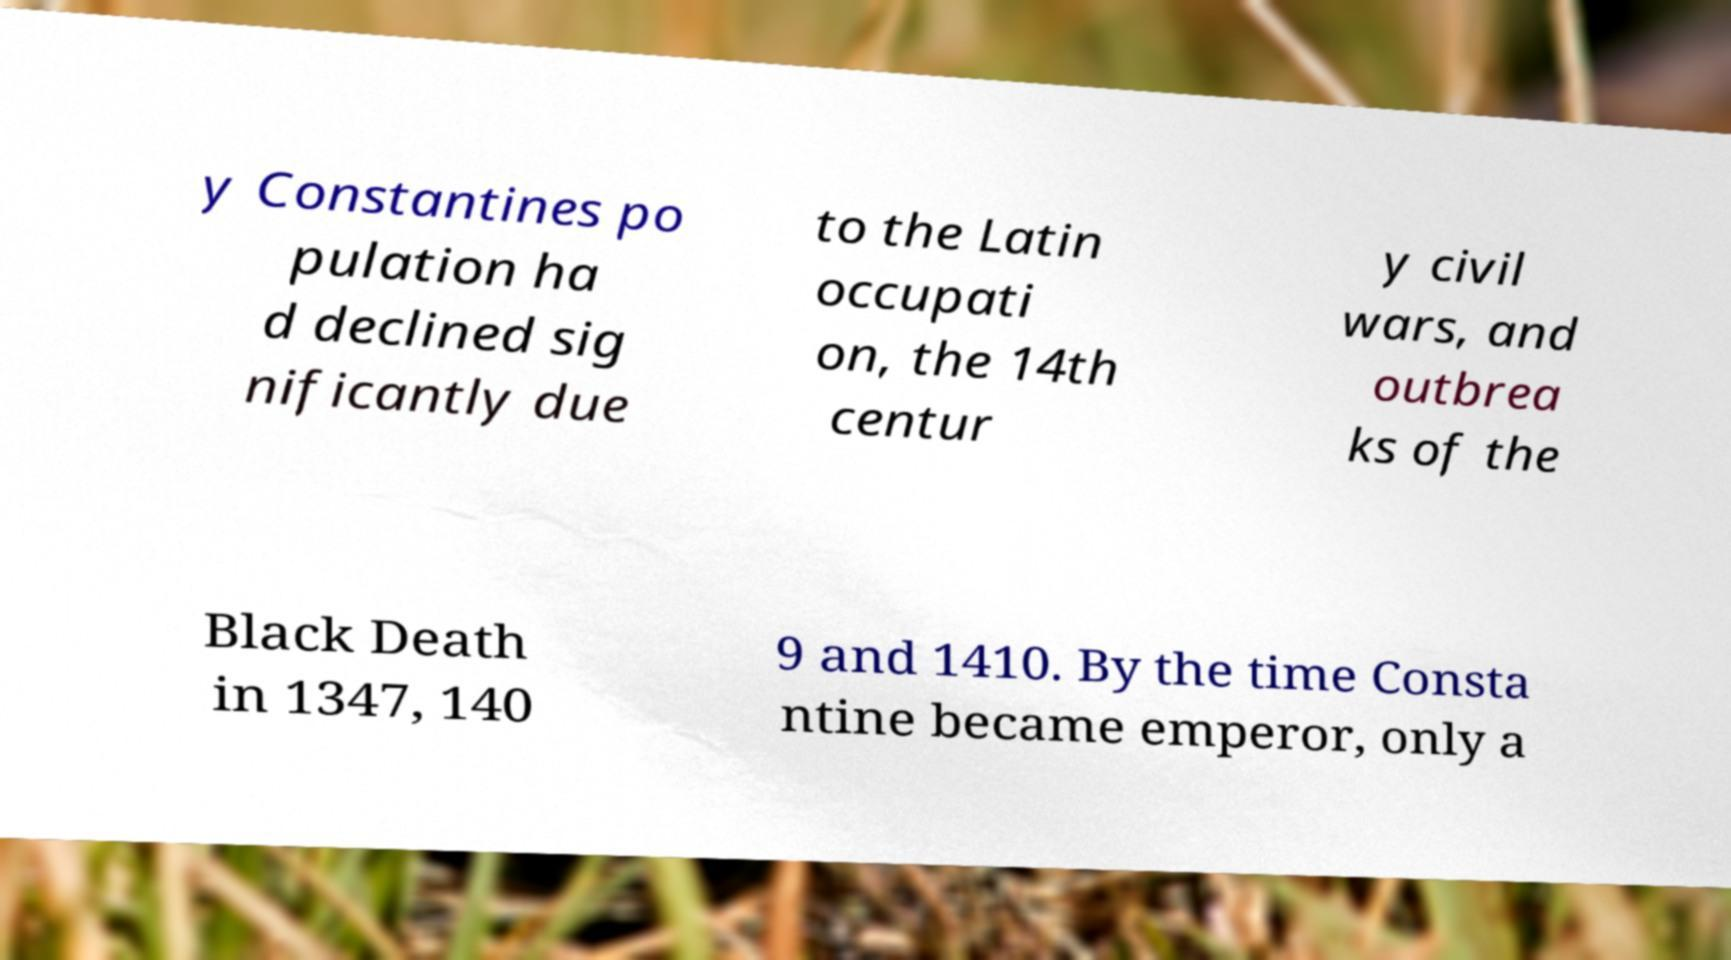I need the written content from this picture converted into text. Can you do that? y Constantines po pulation ha d declined sig nificantly due to the Latin occupati on, the 14th centur y civil wars, and outbrea ks of the Black Death in 1347, 140 9 and 1410. By the time Consta ntine became emperor, only a 